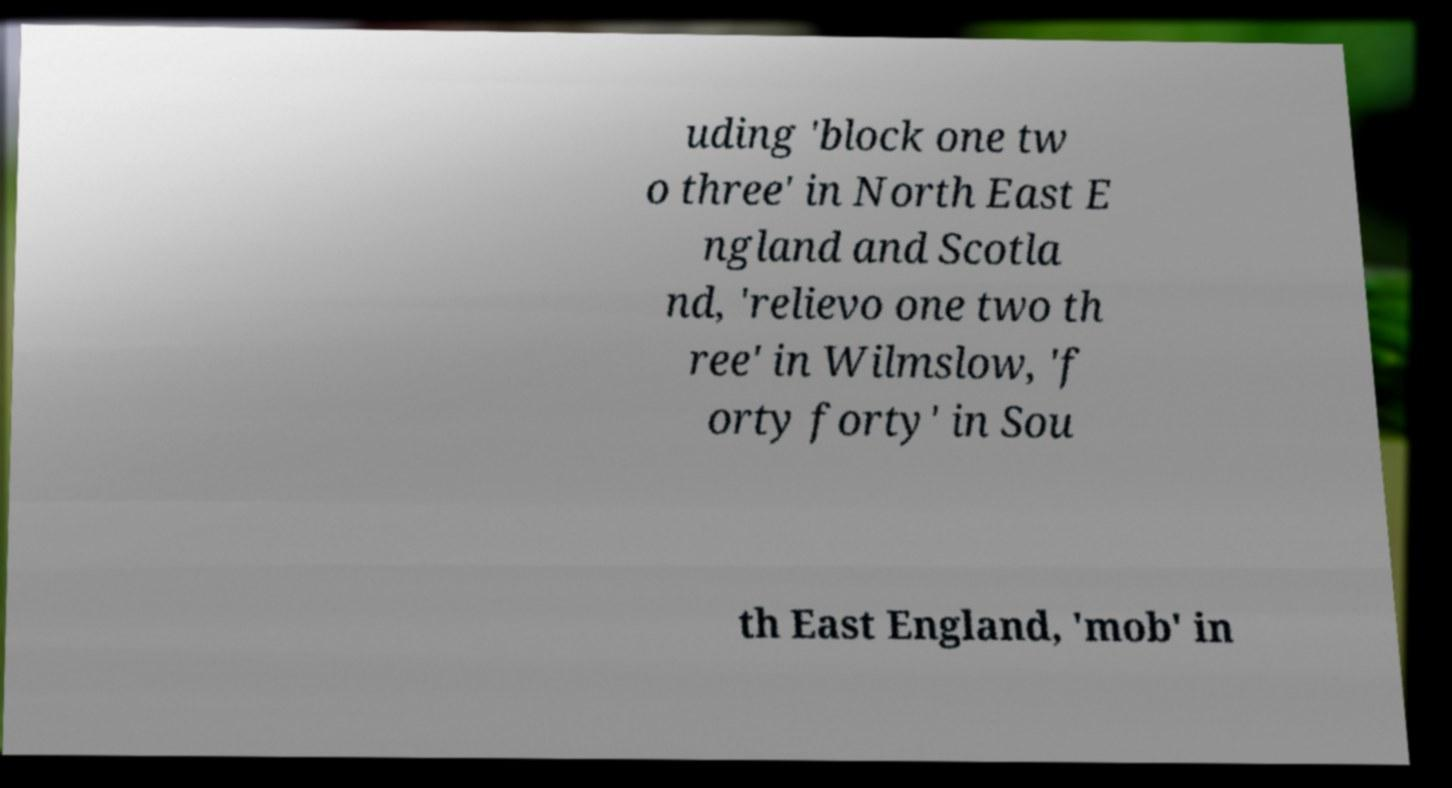There's text embedded in this image that I need extracted. Can you transcribe it verbatim? uding 'block one tw o three' in North East E ngland and Scotla nd, 'relievo one two th ree' in Wilmslow, 'f orty forty' in Sou th East England, 'mob' in 